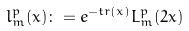Convert formula to latex. <formula><loc_0><loc_0><loc_500><loc_500>l _ { m } ^ { p } ( x ) \colon = e ^ { - t r ( x ) } L _ { m } ^ { p } ( 2 x )</formula> 